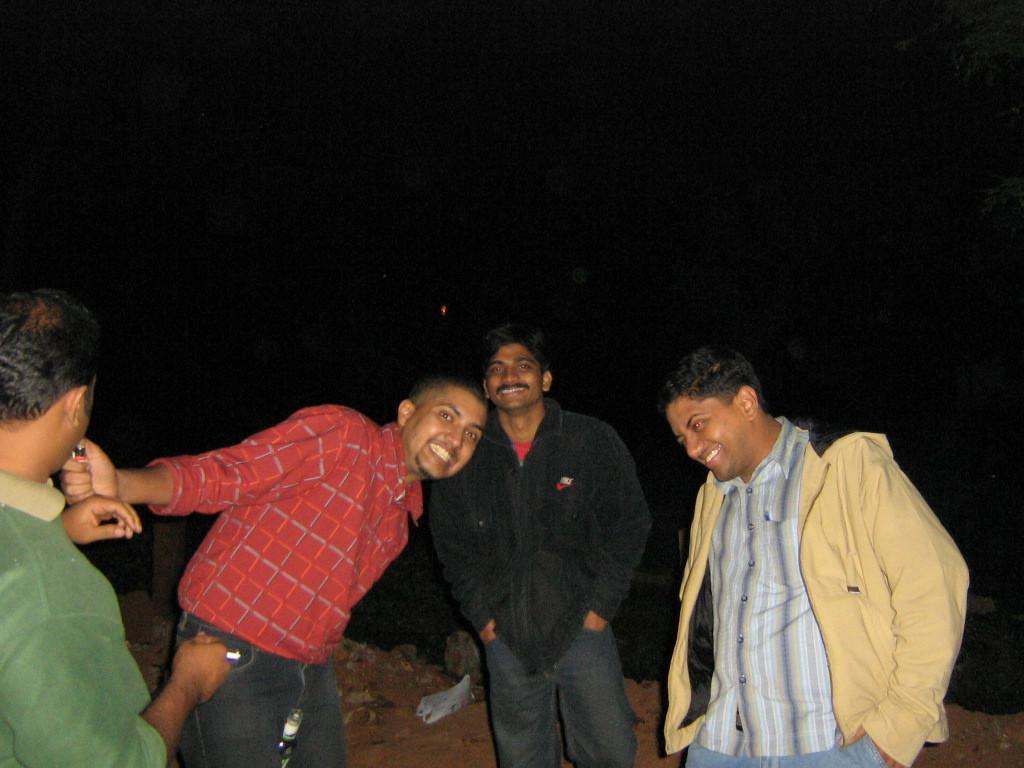How many people are in the image? There are four men in the image. What are the men doing in the image? The men are standing on the ground. What is the facial expression of most of the men? Three of the men are smiling. What is the man holding in his hand? One man is holding an object in his hand. What can be observed about the background of the image? The background of the image is dark. What type of trick can be seen being performed by the man with the object in the image? There is no trick being performed in the image; the man is simply holding an object in his hand. How many quarters can be seen in the image? There are no quarters visible in the image. 